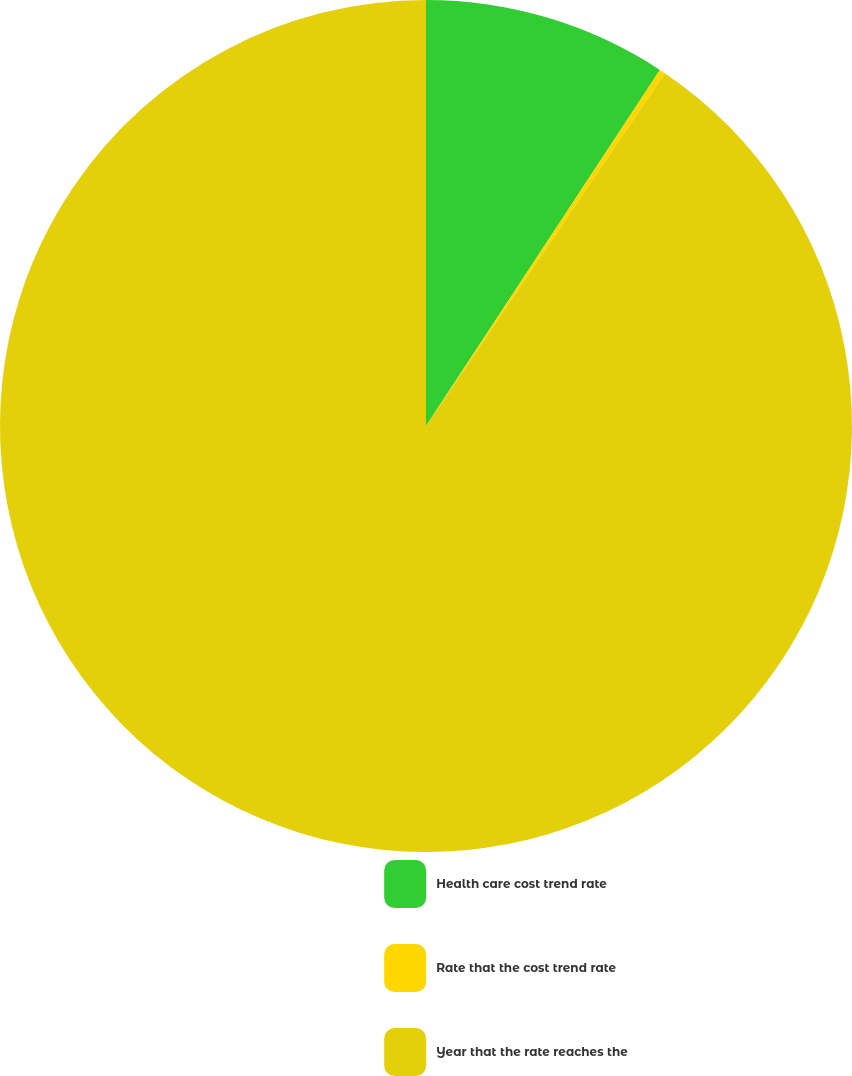<chart> <loc_0><loc_0><loc_500><loc_500><pie_chart><fcel>Health care cost trend rate<fcel>Rate that the cost trend rate<fcel>Year that the rate reaches the<nl><fcel>9.25%<fcel>0.22%<fcel>90.52%<nl></chart> 